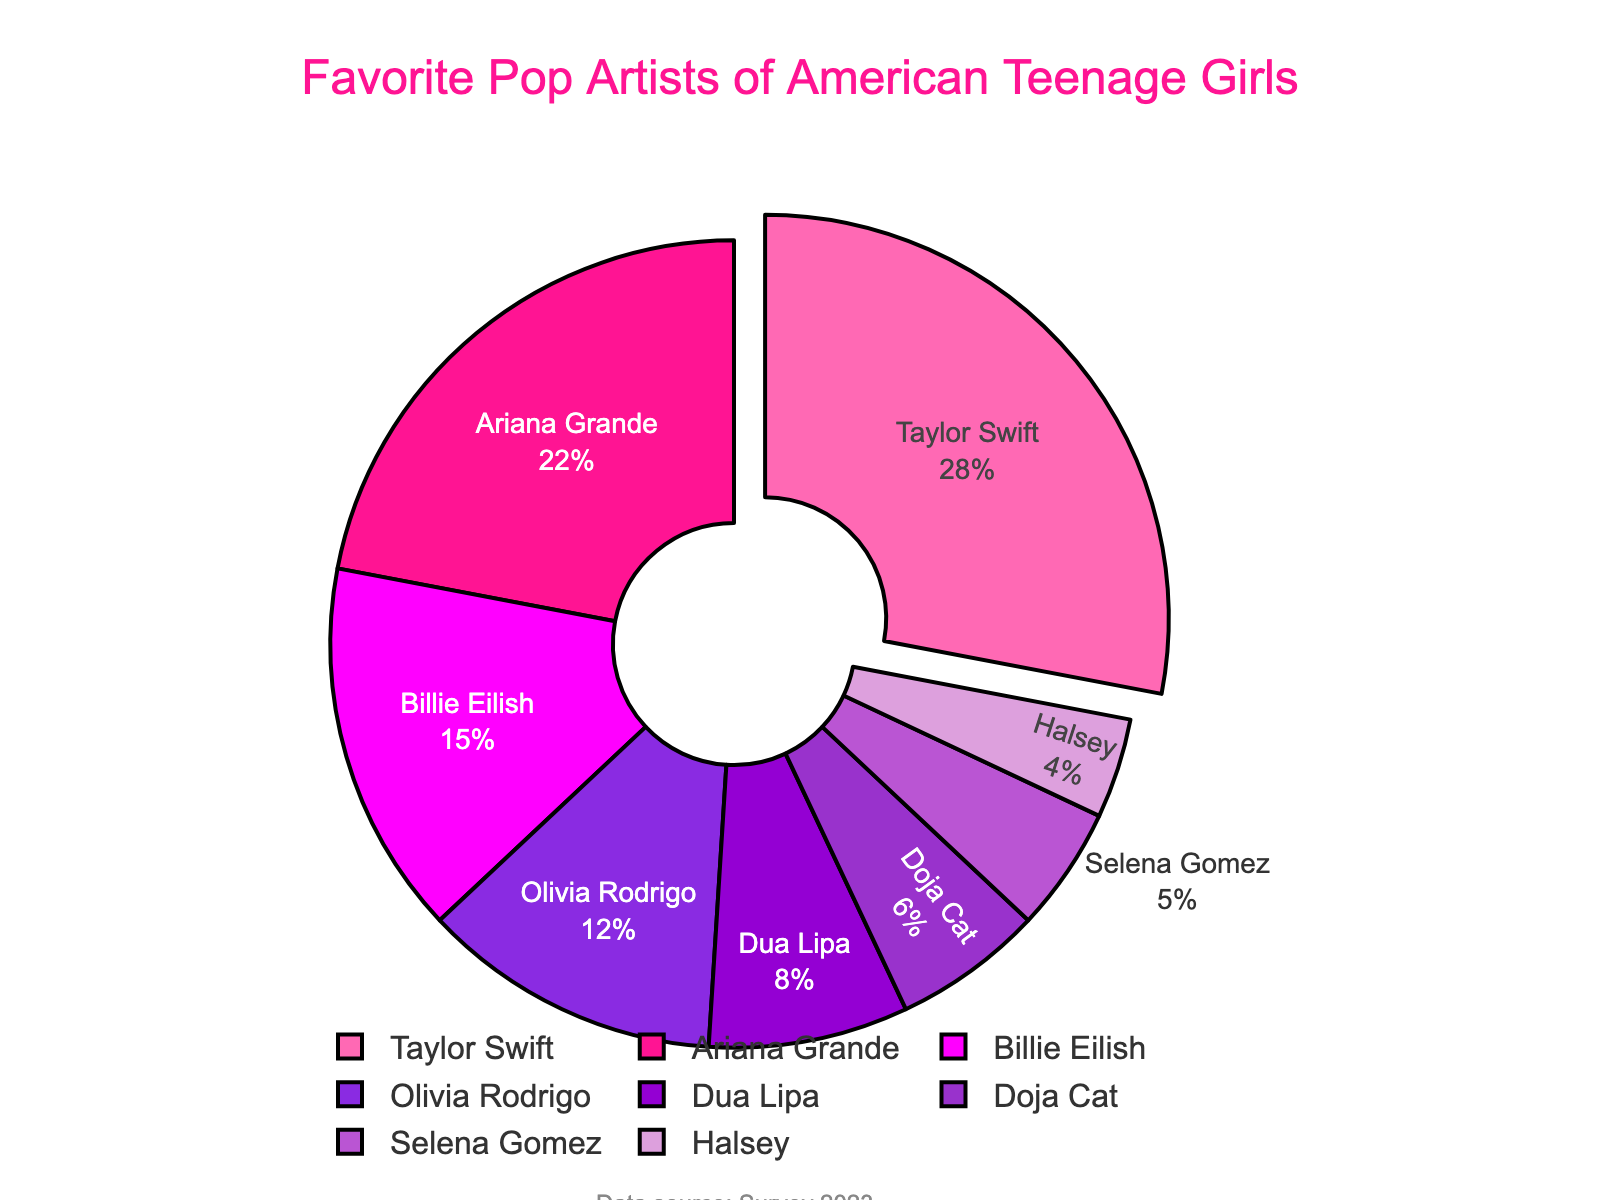Which artist is the most popular among American teenage girls? The largest section of the pie chart represents Taylor Swift, indicating she has the highest percentage preference at 28%
Answer: Taylor Swift Which artist has the smallest percentage of fans? The smallest section of the pie chart represents Halsey, indicating she has the lowest percentage preference at 4%
Answer: Halsey What is the total percentage of fans for Ariana Grande and Dua Lipa combined? The percentage for Ariana Grande is 22% and Dua Lipa is 8%. Adding these together gives 22% + 8% = 30%
Answer: 30% Who is more popular: Billie Eilish or Doja Cat? Billie Eilish has a percentage of 15% whereas Doja Cat has 6%. Therefore, Billie Eilish is more popular
Answer: Billie Eilish Which artist's section is pulled out from the pie chart? The chart highlights only one section that is pulled out, which is Taylor Swift's section
Answer: Taylor Swift How many artists have a percentage above 10%? The artists with percentages above 10% are Taylor Swift (28%), Ariana Grande (22%), Billie Eilish (15%), and Olivia Rodrigo (12%). So there are 4 artists
Answer: 4 What is the average percentage of fans for Selena Gomez, Halsey, and Dua Lipa? The percentages for Selena Gomez, Halsey, and Dua Lipa are 5%, 4%, and 8% respectively. Adding these gives 5% + 4% + 8% = 17%. Dividing by 3 gives 17% / 3 = 5.67%
Answer: 5.67% If a total of 1000 teenagers were surveyed, how many of them are fans of Olivia Rodrigo? Olivia Rodrigo has 12%. Therefore, 12% of 1000 is calculated as (12/100) * 1000 = 120
Answer: 120 